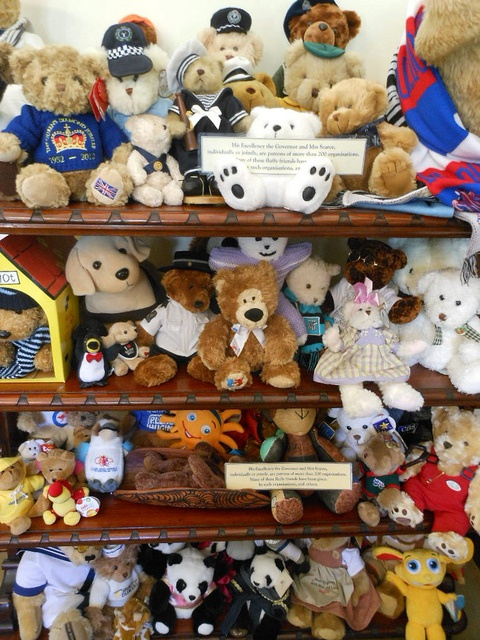Describe the objects in this image and their specific colors. I can see teddy bear in olive, black, maroon, darkgray, and gray tones, teddy bear in olive, tan, blue, lightgray, and red tones, teddy bear in olive, tan, and navy tones, teddy bear in olive, brown, tan, and maroon tones, and teddy bear in olive, brown, tan, and darkgray tones in this image. 